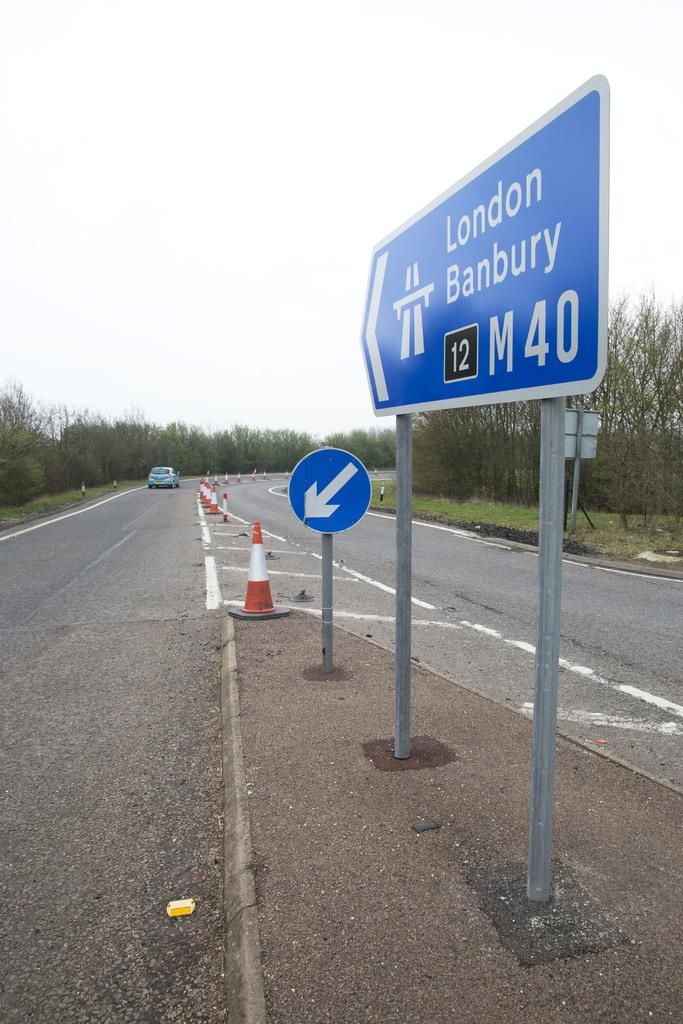<image>
Give a short and clear explanation of the subsequent image. A blue sign announces the London Banbury M40 highway. 